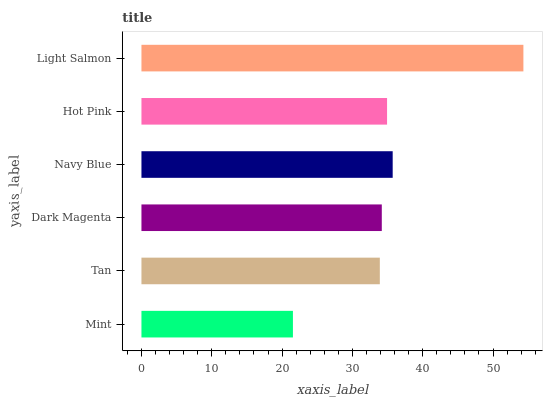Is Mint the minimum?
Answer yes or no. Yes. Is Light Salmon the maximum?
Answer yes or no. Yes. Is Tan the minimum?
Answer yes or no. No. Is Tan the maximum?
Answer yes or no. No. Is Tan greater than Mint?
Answer yes or no. Yes. Is Mint less than Tan?
Answer yes or no. Yes. Is Mint greater than Tan?
Answer yes or no. No. Is Tan less than Mint?
Answer yes or no. No. Is Hot Pink the high median?
Answer yes or no. Yes. Is Dark Magenta the low median?
Answer yes or no. Yes. Is Light Salmon the high median?
Answer yes or no. No. Is Light Salmon the low median?
Answer yes or no. No. 